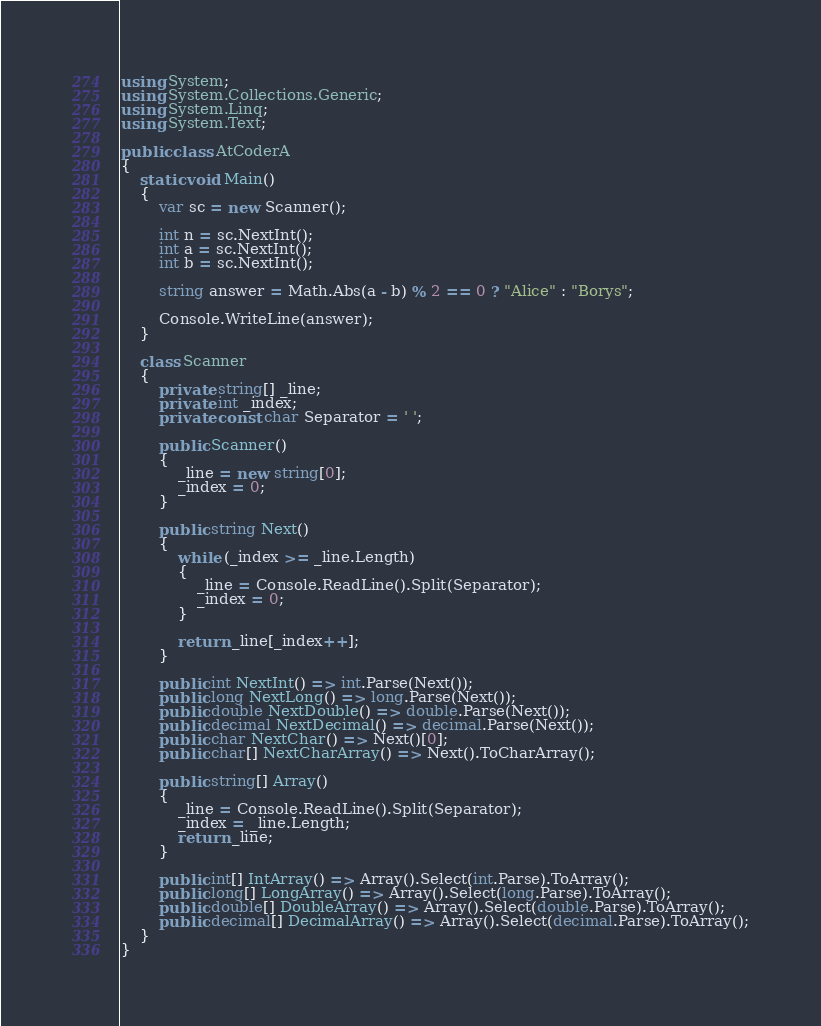<code> <loc_0><loc_0><loc_500><loc_500><_C#_>using System;
using System.Collections.Generic;
using System.Linq;
using System.Text;

public class AtCoderA
{
    static void Main()
    {
        var sc = new Scanner();

        int n = sc.NextInt();
        int a = sc.NextInt();
        int b = sc.NextInt();

        string answer = Math.Abs(a - b) % 2 == 0 ? "Alice" : "Borys";

        Console.WriteLine(answer);
    }

    class Scanner
    {
        private string[] _line;
        private int _index;
        private const char Separator = ' ';

        public Scanner()
        {
            _line = new string[0];
            _index = 0;
        }

        public string Next()
        {
            while (_index >= _line.Length)
            {
                _line = Console.ReadLine().Split(Separator);
                _index = 0;
            }

            return _line[_index++];
        }

        public int NextInt() => int.Parse(Next());
        public long NextLong() => long.Parse(Next());
        public double NextDouble() => double.Parse(Next());
        public decimal NextDecimal() => decimal.Parse(Next());
        public char NextChar() => Next()[0];
        public char[] NextCharArray() => Next().ToCharArray();

        public string[] Array()
        {
            _line = Console.ReadLine().Split(Separator);
            _index = _line.Length;
            return _line;
        }

        public int[] IntArray() => Array().Select(int.Parse).ToArray();
        public long[] LongArray() => Array().Select(long.Parse).ToArray();
        public double[] DoubleArray() => Array().Select(double.Parse).ToArray();
        public decimal[] DecimalArray() => Array().Select(decimal.Parse).ToArray();
    }
}</code> 